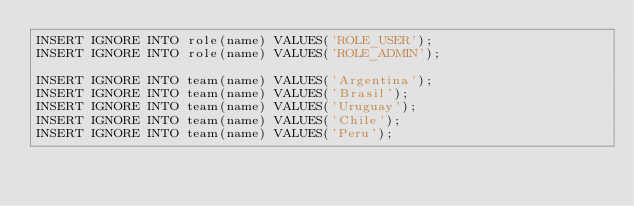<code> <loc_0><loc_0><loc_500><loc_500><_SQL_>INSERT IGNORE INTO role(name) VALUES('ROLE_USER');
INSERT IGNORE INTO role(name) VALUES('ROLE_ADMIN');

INSERT IGNORE INTO team(name) VALUES('Argentina');
INSERT IGNORE INTO team(name) VALUES('Brasil');
INSERT IGNORE INTO team(name) VALUES('Uruguay');
INSERT IGNORE INTO team(name) VALUES('Chile');
INSERT IGNORE INTO team(name) VALUES('Peru');
</code> 